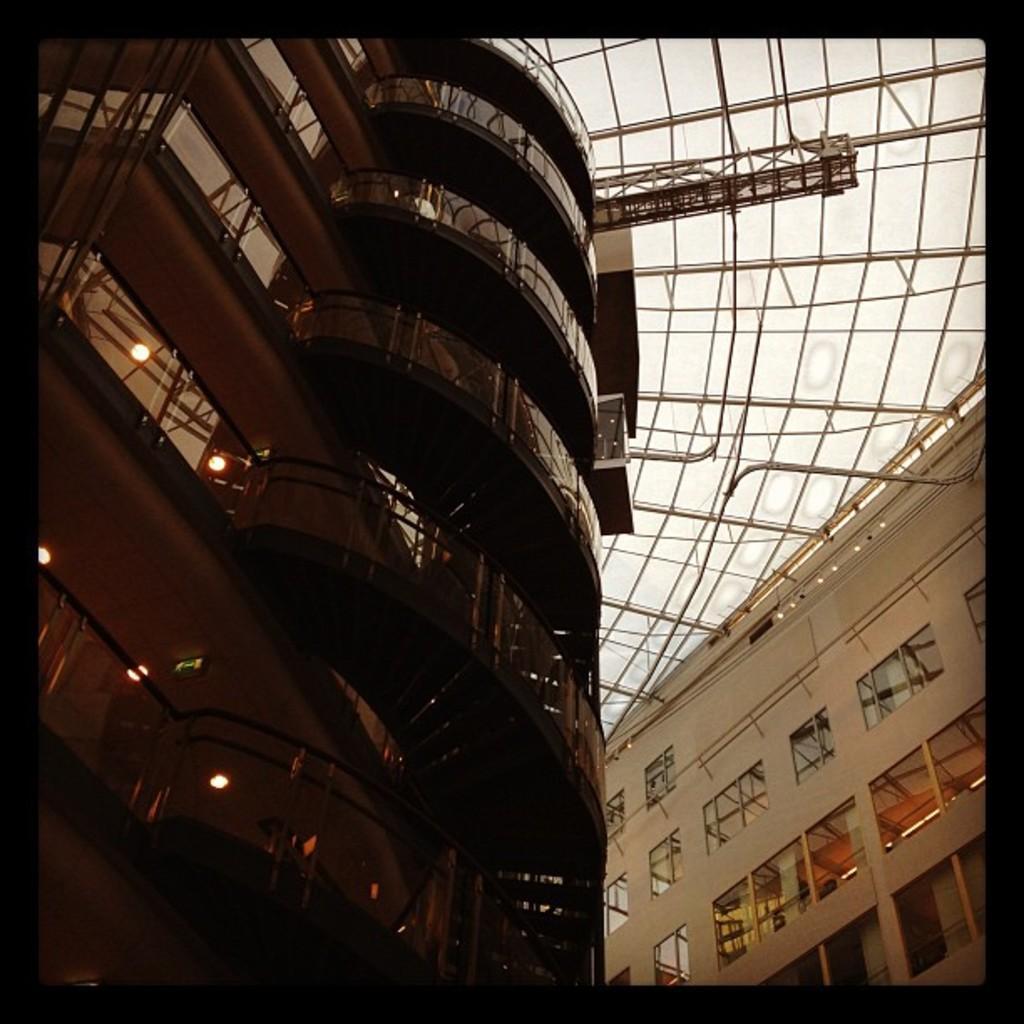Could you give a brief overview of what you see in this image? In this image I can see a building which is brown in color and another building which is cream in color. I can see few windows of the building through which I can see few lights. I can see the ceiling of the building which is cream in color. 